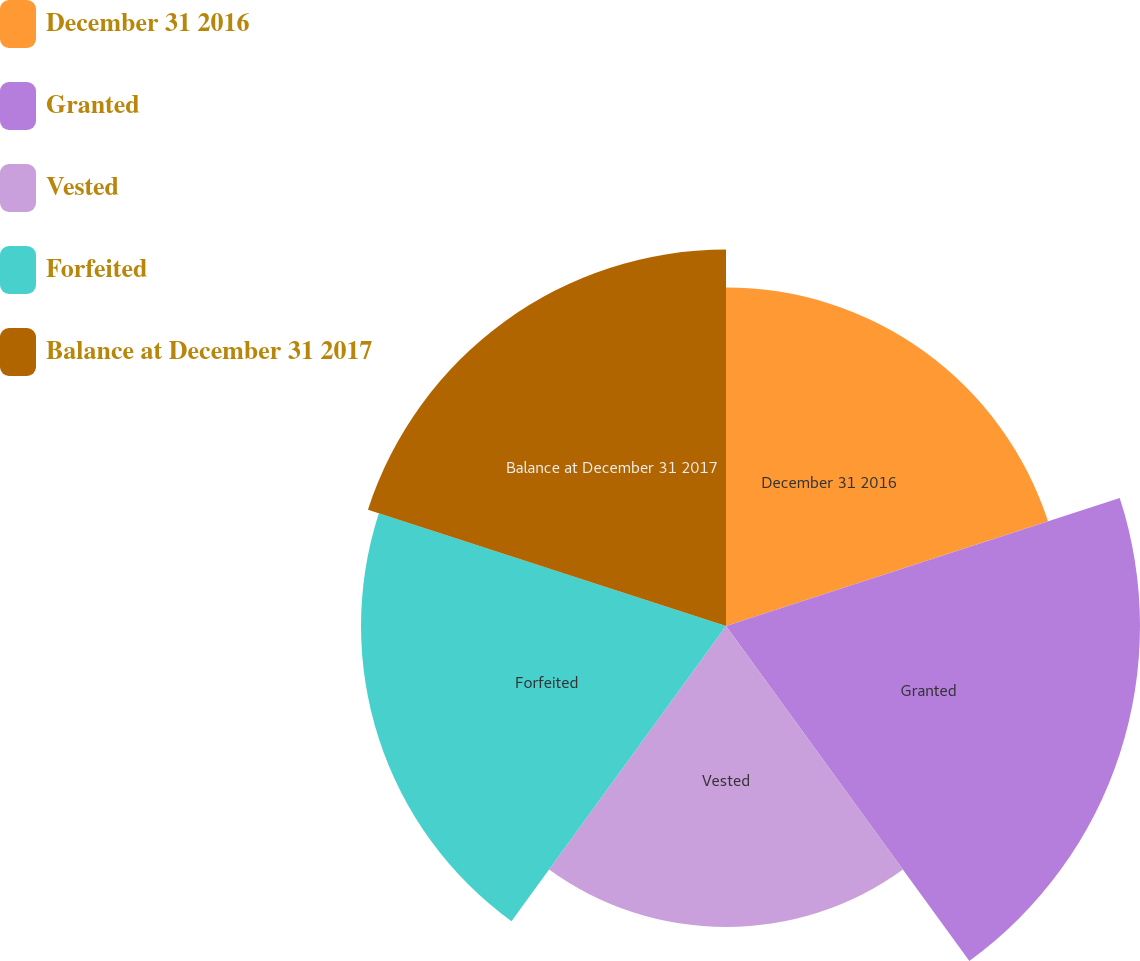Convert chart to OTSL. <chart><loc_0><loc_0><loc_500><loc_500><pie_chart><fcel>December 31 2016<fcel>Granted<fcel>Vested<fcel>Forfeited<fcel>Balance at December 31 2017<nl><fcel>18.86%<fcel>23.06%<fcel>16.77%<fcel>20.33%<fcel>20.97%<nl></chart> 